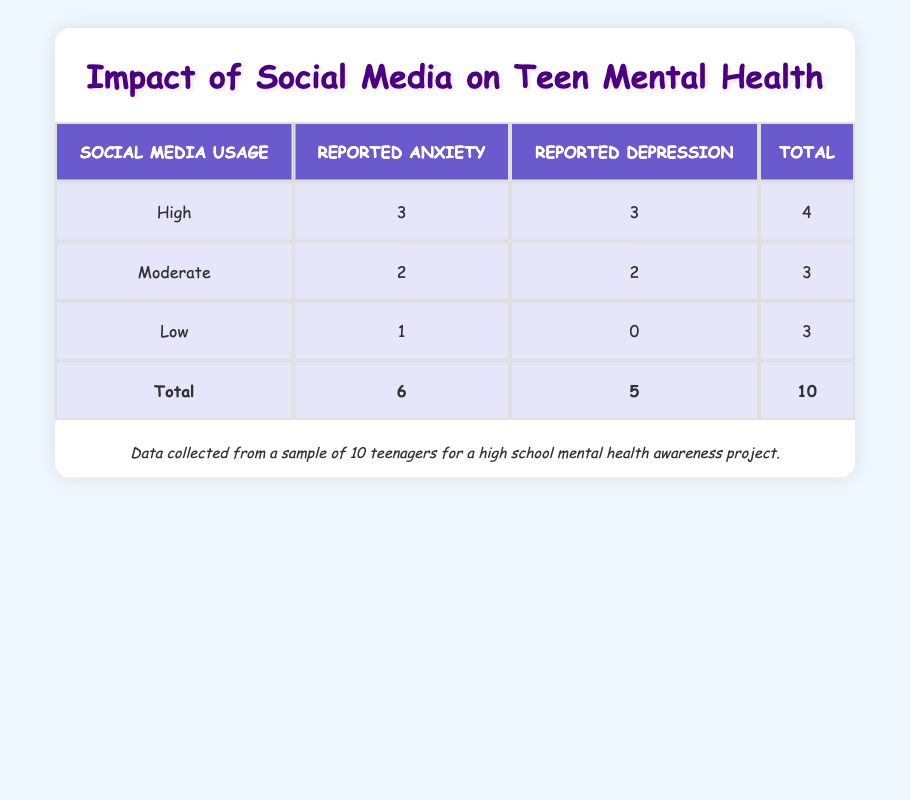What is the total number of teenagers who reported anxiety? To find the total number of teenagers who reported anxiety, we look at the "Reported Anxiety" column. Adding the values from each social media usage category: High (3) + Moderate (2) + Low (1) = 6.
Answer: 6 How many teenagers reported depression under high social media usage? The "Reported Depression" count for the high social media usage category is 3. This value can be read directly from the corresponding row in the table.
Answer: 3 What is the total number of teenagers who have low social media usage? The table shows that there are 3 teenagers categorized under low social media usage. This value is found in the "Total" column for low usage.
Answer: 3 Are there any teenagers who reported both anxiety and depression under moderate social media usage? Yes, the moderate category shows that 2 teenagers reported anxiety and 2 reported depression. Both values imply that at least one of them reported both conditions.
Answer: Yes What is the difference in the number of teenagers reporting anxiety between high and moderate social media usage? From the table, we see that 3 teenagers reported anxiety under high social media usage and 2 reported anxiety under moderate social media usage. The difference is calculated as 3 - 2 = 1.
Answer: 1 How many teenagers reported neither anxiety nor depression with low social media usage? In the low social media usage category, there are 3 teenagers, and the area shows that only 1 reported anxiety and none reported depression, indicating that 2 teenagers reported neither. Thus, the calculation is 3 (total) - 1 (anxiety) = 2.
Answer: 2 What percentage of teenagers with high social media usage reported depression? There are a total of 4 teenagers with high social media usage. Out of these, 3 reported depression. To find the percentage, we use the formula (3/4) * 100, which gives us 75%.
Answer: 75% If a teenager reports anxiety, what is the likelihood they also report depression, based on the data? Out of the 6 teenagers who reported anxiety, 4 also reported depression (3 from high usage and 1 from moderate usage). Thus, the likelihood is calculated as (4/6) or approximately 66.67%, meaning 2 out of 3 chance roughly.
Answer: 66.67% How many total teenagers did not report any mental health issues? The table indicates from the "Reported Anxiety" and "Reported Depression" columns that only teenagers with low social media usage reported neither condition. Thus, there are 2 teenagers (3 total - 1 anxiety).
Answer: 2 